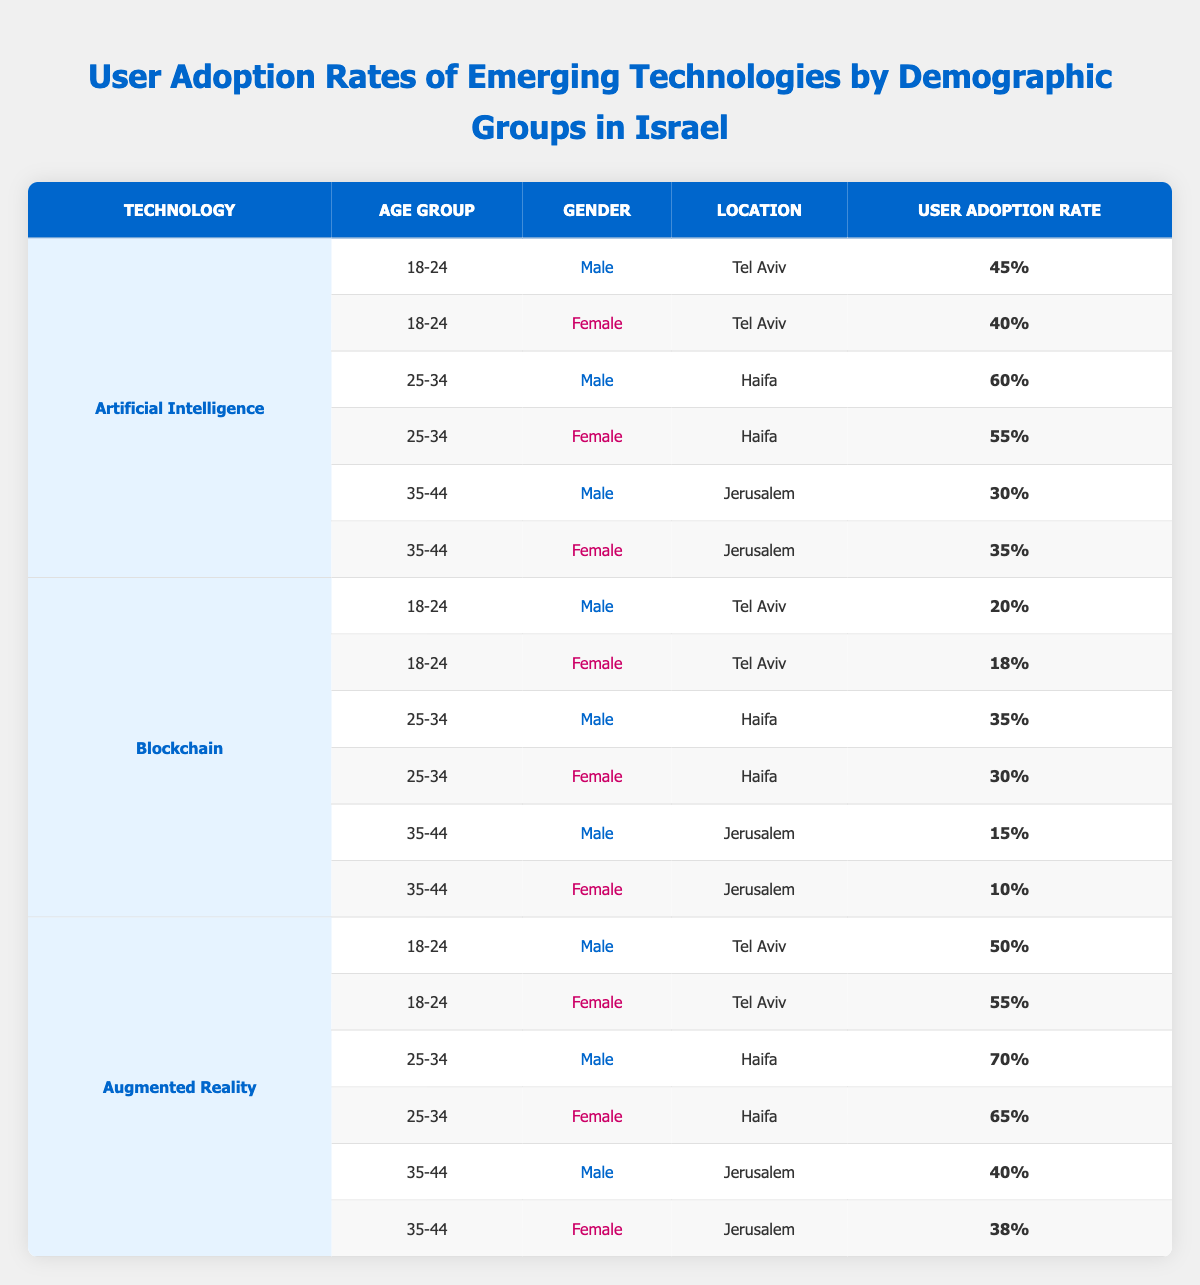What is the highest user adoption rate for Artificial Intelligence among the age group 25-34? The adoption rate for males in this age group is 60% in Haifa, while for females it is 55%. Thus, 60% is the highest rate among the 25-34 age group for Artificial Intelligence.
Answer: 60% Which gender has a higher user adoption rate for Blockchain in the 18-24 age group? The adoption rate for males in this group is 20% while for females it is 18%. This means that males have a higher user adoption rate for Blockchain in the 18-24 category.
Answer: Male What is the average user adoption rate for Augmented Reality among females aged 25-34? The rates for females in this age group are 65%. Since there is only one data point, the average is 65% itself.
Answer: 65% Is the user adoption rate for males in Jerusalem higher for Artificial Intelligence than for Blockchain in the age group 35-44? The rate for males in Jerusalem for Artificial Intelligence is 30% while for Blockchain it is 15%. Therefore, the rate for Artificial Intelligence is higher.
Answer: Yes What is the total user adoption rate for males across all technologies in the 25-34 age group? For males in the 25-34 age group, the rates are 60% for Artificial Intelligence, 35% for Blockchain, and 70% for Augmented Reality. Summing these gives us 60 + 35 + 70 = 165%. The total user adoption rate is 165%.
Answer: 165% 